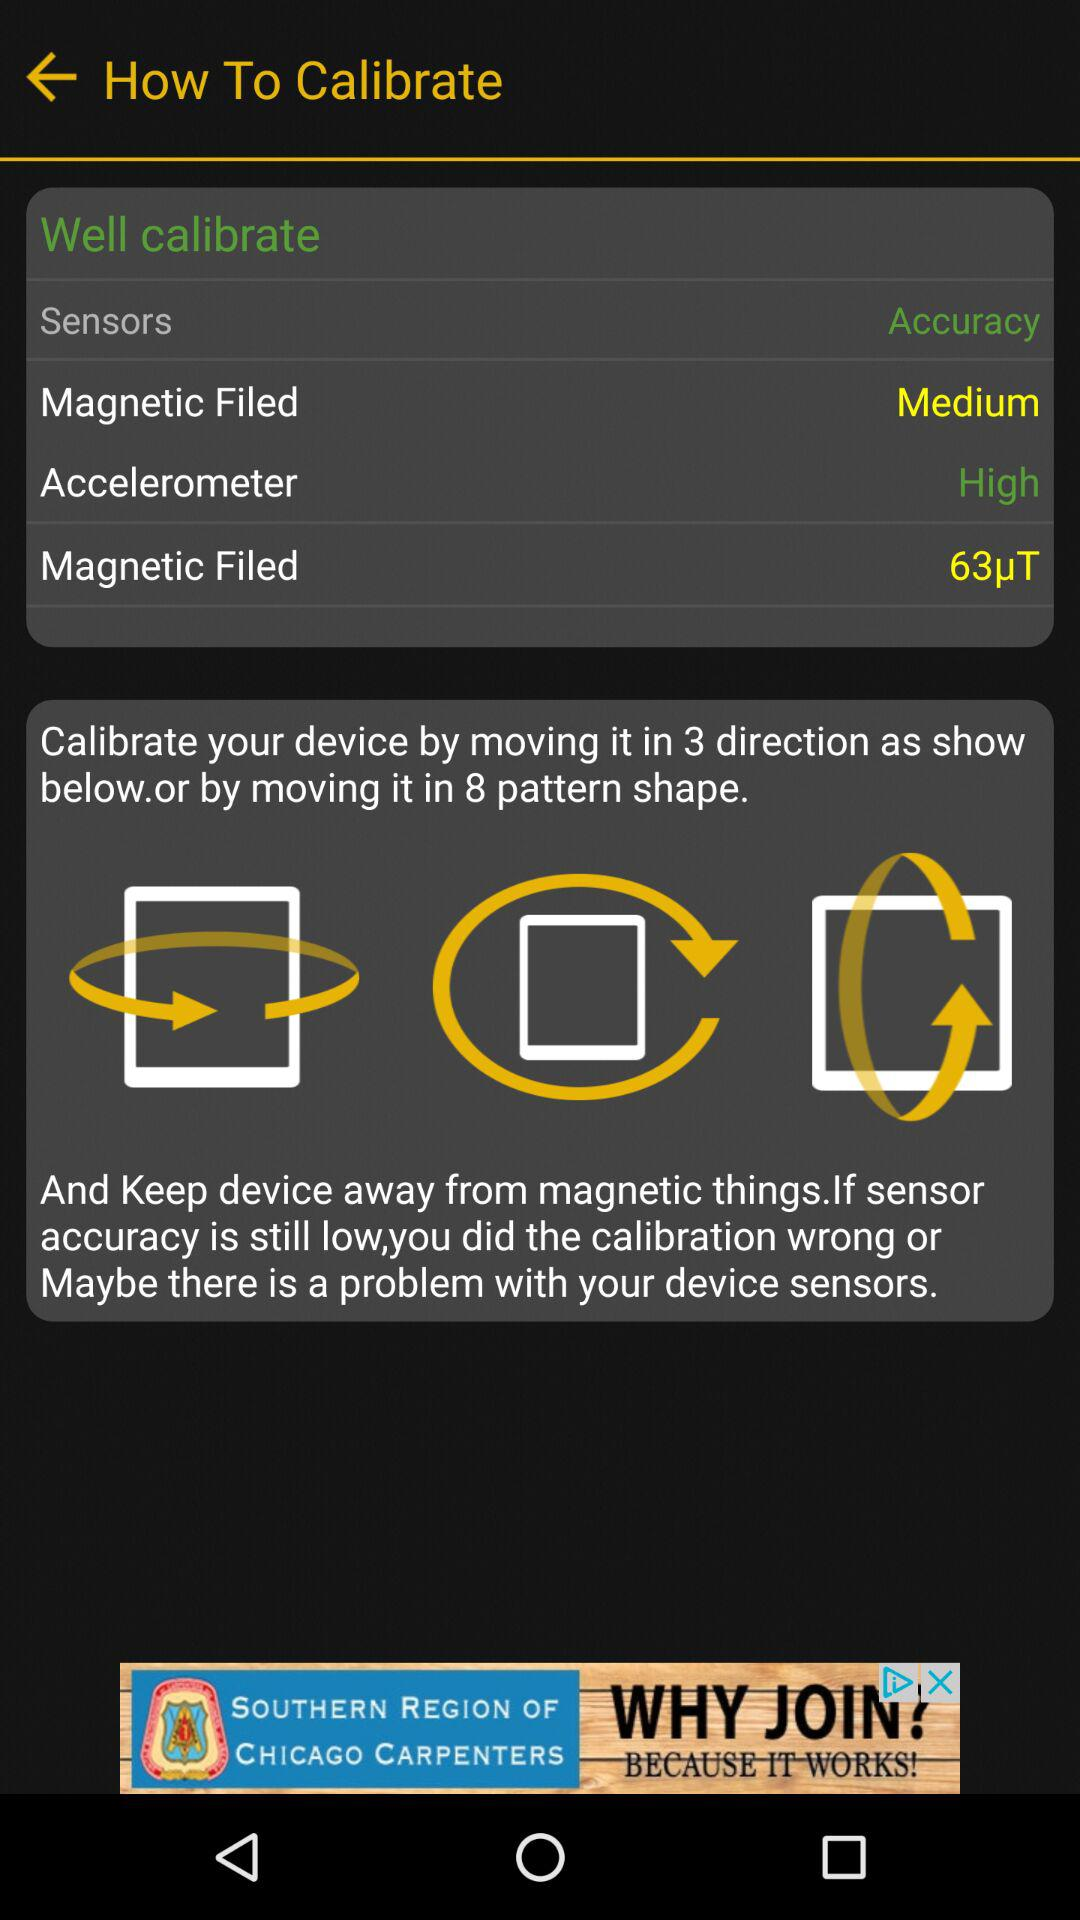How many sensors are shown in the calibration screen?
Answer the question using a single word or phrase. 3 